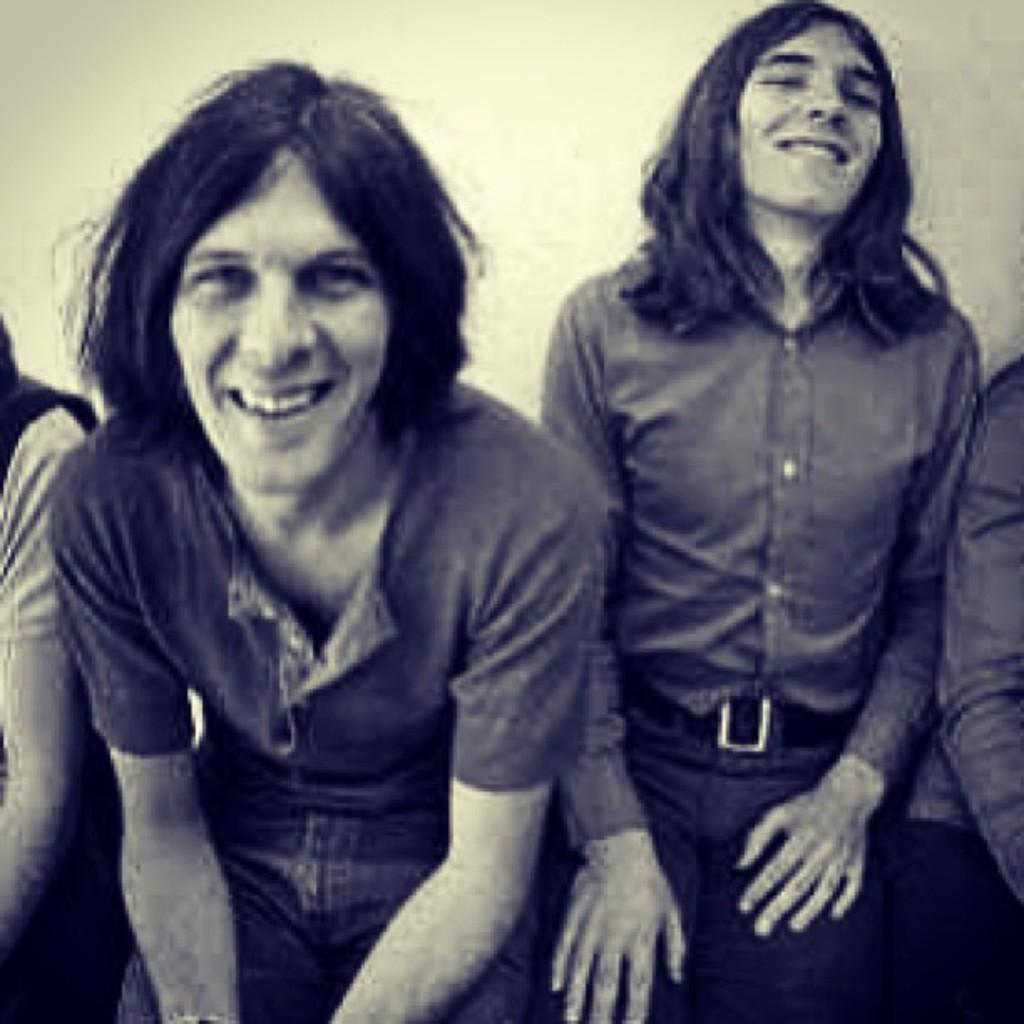What are the people in the image doing? The people in the image are sitting. What is the facial expression of some of the people in the image? Two of them are smiling. What can be seen behind the people in the image? There is a wall behind them. How is the image presented in terms of color? The image is in black and white mode. What type of shop can be seen in the image? There is no shop present in the image. How many men are visible in the image? The provided facts do not specify the gender of the people in the image, so we cannot determine the number of men. 